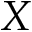Convert formula to latex. <formula><loc_0><loc_0><loc_500><loc_500>X</formula> 